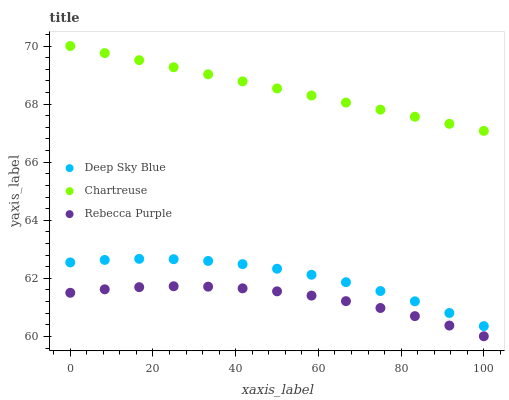Does Rebecca Purple have the minimum area under the curve?
Answer yes or no. Yes. Does Chartreuse have the maximum area under the curve?
Answer yes or no. Yes. Does Deep Sky Blue have the minimum area under the curve?
Answer yes or no. No. Does Deep Sky Blue have the maximum area under the curve?
Answer yes or no. No. Is Chartreuse the smoothest?
Answer yes or no. Yes. Is Deep Sky Blue the roughest?
Answer yes or no. Yes. Is Rebecca Purple the smoothest?
Answer yes or no. No. Is Rebecca Purple the roughest?
Answer yes or no. No. Does Rebecca Purple have the lowest value?
Answer yes or no. Yes. Does Deep Sky Blue have the lowest value?
Answer yes or no. No. Does Chartreuse have the highest value?
Answer yes or no. Yes. Does Deep Sky Blue have the highest value?
Answer yes or no. No. Is Deep Sky Blue less than Chartreuse?
Answer yes or no. Yes. Is Deep Sky Blue greater than Rebecca Purple?
Answer yes or no. Yes. Does Deep Sky Blue intersect Chartreuse?
Answer yes or no. No. 